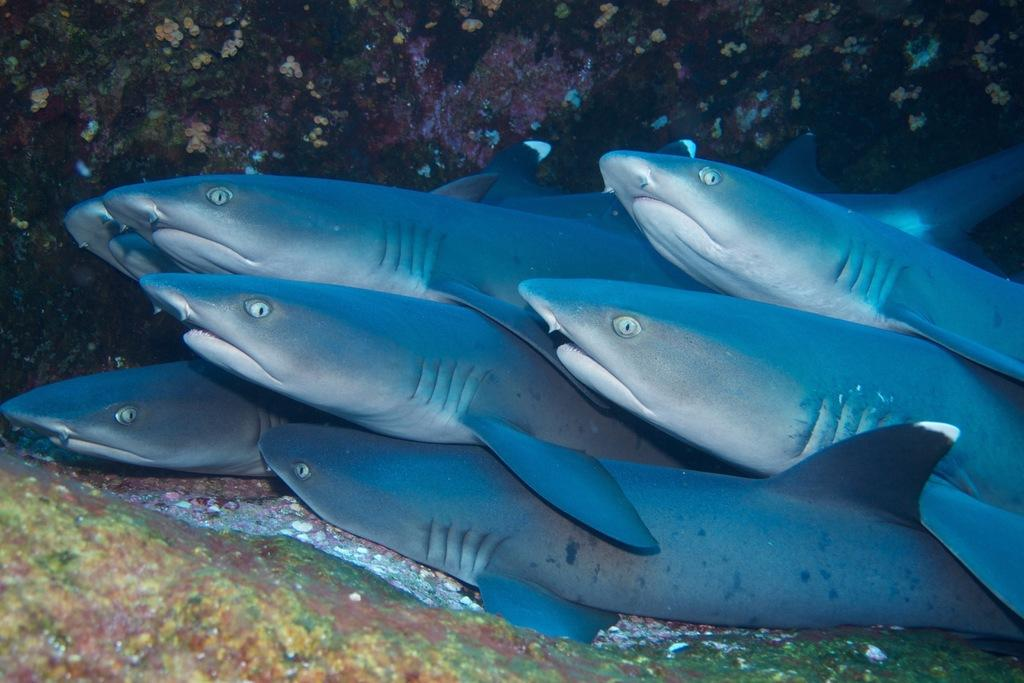What type of animals can be seen in the water in the image? There are fishes in the water in the image. What type of learning can be observed taking place at night in the image? There is no learning or nighttime activity depicted in the image, as it features fishes in the water. 